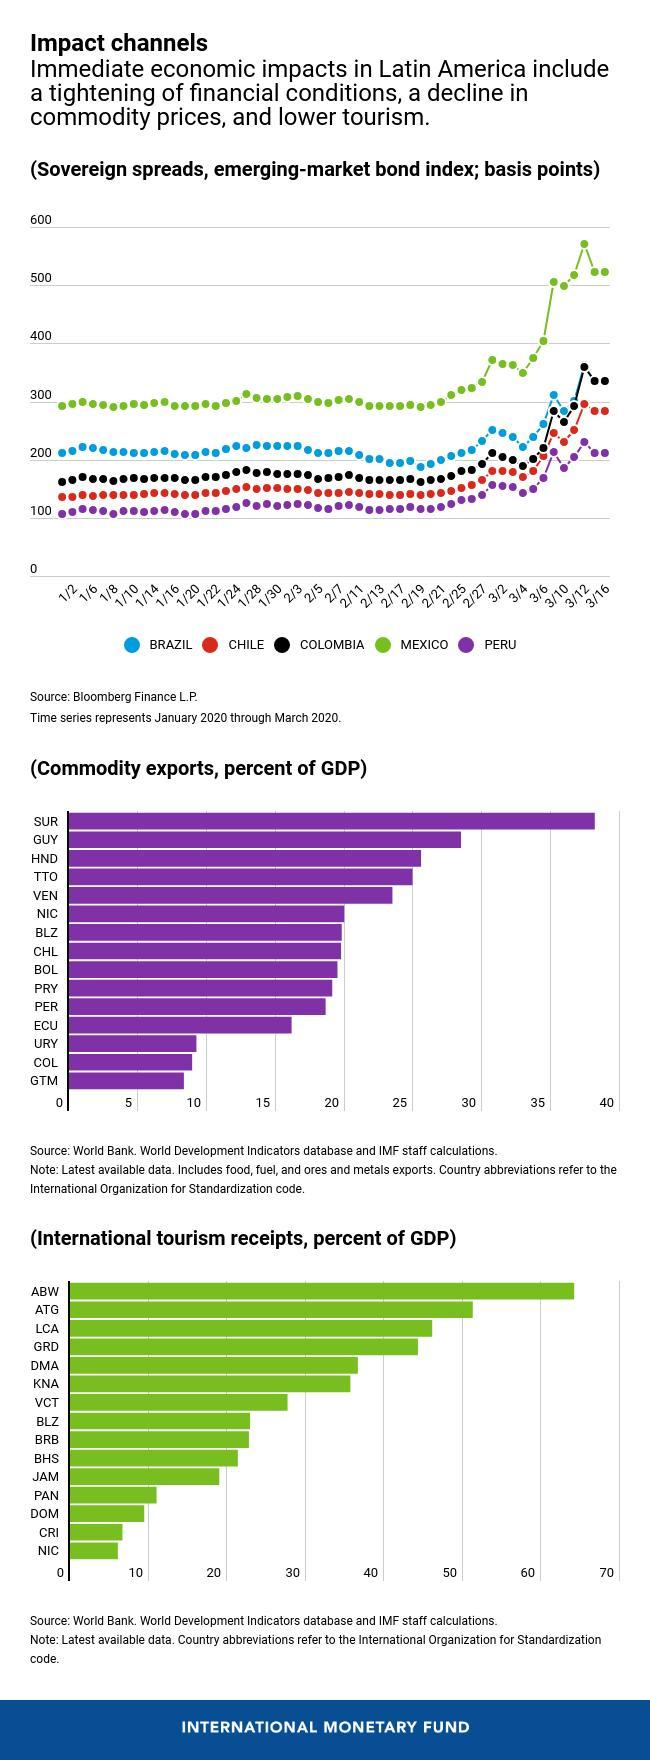How many countries have commodity export which adds to less than twenty five percent of GDP?
Answer the question with a short phrase. 3 What is the color code given to Chile- yellow, red, purple, black? red Which country in Latin America has largest sovereign spread? Mexico Which country has the third highest position in commodity exports in terms of GDP? HND On which day of March Mexico crossed the 500 margin? 3/10 On which day of March Colombia crossed the 300 margin? 3/12 What is the color code given to Colombia- yellow, red, purple, black? black How many country's international tourism adds to less than 10% of GDP? 3 How many country's international tourism adds to more than 50% of GDP? 2 Which country has the fourth highest position in commodity exports in terms of GDP? TTO 